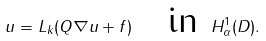Convert formula to latex. <formula><loc_0><loc_0><loc_500><loc_500>u = L _ { k } ( Q \nabla u + f ) \quad \text {in } H ^ { 1 } _ { \alpha } ( D ) .</formula> 